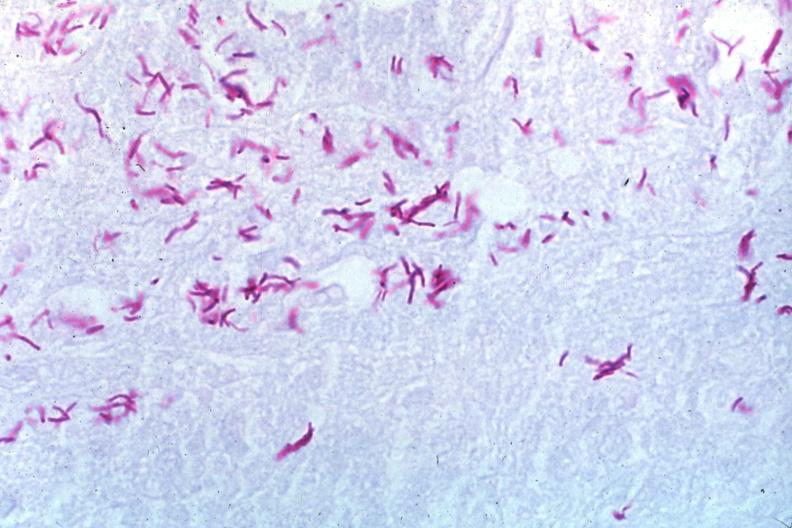does basilar skull fracture stain a zillion organisms?
Answer the question using a single word or phrase. No 